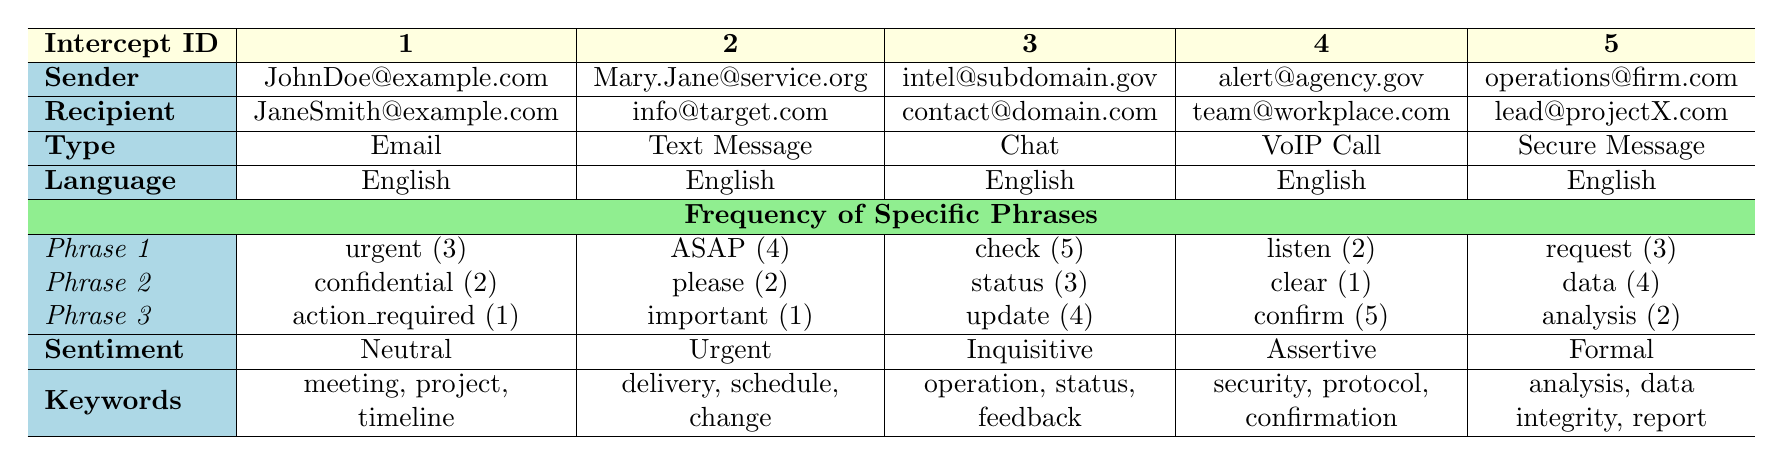What is the communication type for intercept ID 3? The table shows that for intercept ID 3, the communication type is "Chat". This information is directly retrieved from the communication type column corresponding to intercept ID 3.
Answer: Chat Which sender used the phrase "ASAP" the most? The phrase "ASAP" appears 4 times in the communication from Mary.Jane@service.org, which is more than any other sender. By comparing the frequencies of "ASAP" across all senders, it is clear that Mary.Jane@service.org has the highest count.
Answer: Mary.Jane@service.org Is the sentiment analysis for intercept ID 5 formal? The sentiment analysis for intercept ID 5 is indeed labeled as "Formal." This is directly observable from the sentiment analysis column corresponding to intercept ID 5.
Answer: Yes What is the total frequency of specific phrases for intercept ID 1? For intercept ID 1, the total frequency is the sum of the counts for each specific phrase: 3 (urgent) + 2 (confidential) + 1 (action required) = 6. This calculation is performed by adding together all specific phrase frequencies.
Answer: 6 Which intercept has the highest number of frequency for the phrase "confirm"? The phrase "confirm" appears 5 times in the communication from alert@agency.gov, which is higher than any other instances of "confirm". By checking the frequency of "confirm" across all intercepts, it's clear that intercept ID 4 has the highest count.
Answer: Intercept ID 4 How many context keywords are associated with intercept ID 2? Intercept ID 2 has 3 context keywords: "delivery", "schedule", and "change." These are retrieved from the keywords column corresponding to intercept ID 2.
Answer: 3 What is the average frequency of the phrase "status" across all intercepts? The phrase "status" appears as follows: 0 (not present for the first) + 0 + 3 + 0 + 0 = 3. Since it appears only once, the average frequency is 3 divided by the number of intercepts which is 5, leading to an average of 0.6.
Answer: 0.6 Which two intercepts have "English" as their language? All the intercepts listed in the table have "English" as their language, as seen from the language used column. This is verified by checking each row for its corresponding language.
Answer: All Intercepts Is there a record of an email being sent that included the keyword "timeline"? Yes, intercept ID 1, which is an email communication, contains the keyword "timeline" in its context keywords. This can be confirmed by reviewing the context keywords for the specific intercept.
Answer: Yes 